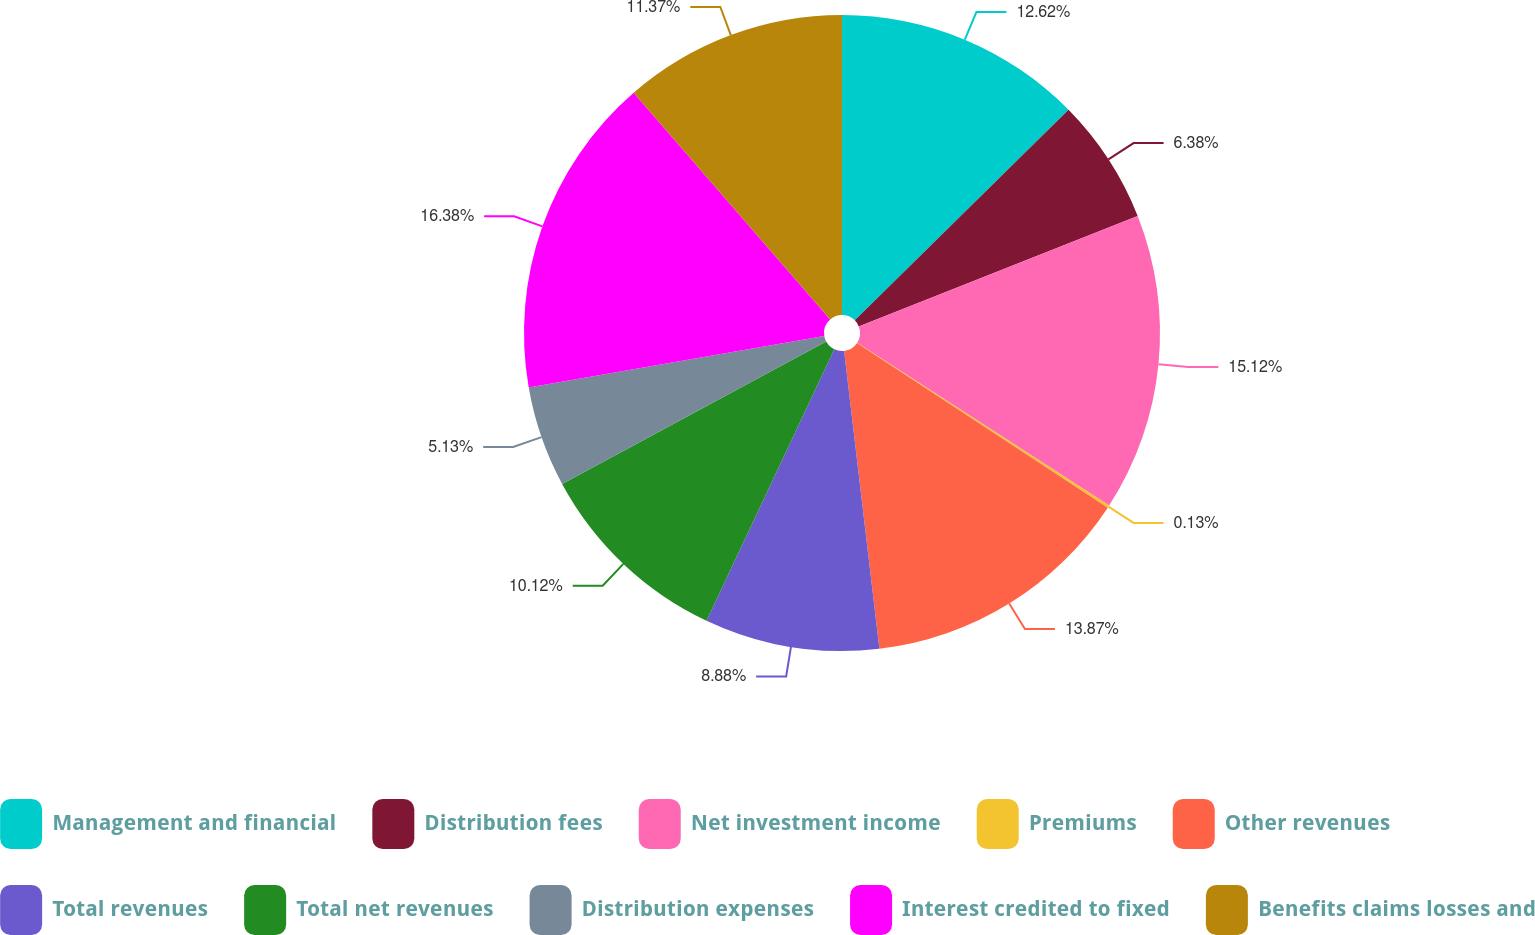<chart> <loc_0><loc_0><loc_500><loc_500><pie_chart><fcel>Management and financial<fcel>Distribution fees<fcel>Net investment income<fcel>Premiums<fcel>Other revenues<fcel>Total revenues<fcel>Total net revenues<fcel>Distribution expenses<fcel>Interest credited to fixed<fcel>Benefits claims losses and<nl><fcel>12.62%<fcel>6.38%<fcel>15.12%<fcel>0.13%<fcel>13.87%<fcel>8.88%<fcel>10.12%<fcel>5.13%<fcel>16.37%<fcel>11.37%<nl></chart> 